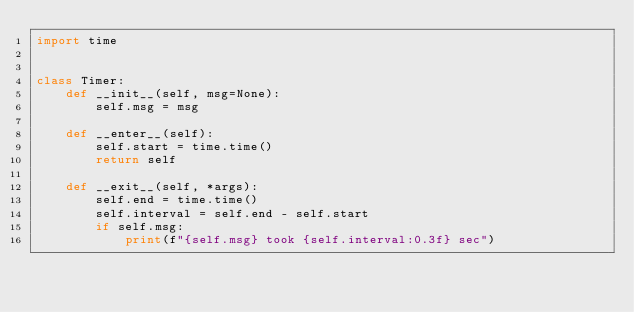Convert code to text. <code><loc_0><loc_0><loc_500><loc_500><_Python_>import time


class Timer:
    def __init__(self, msg=None):
        self.msg = msg

    def __enter__(self):
        self.start = time.time()
        return self

    def __exit__(self, *args):
        self.end = time.time()
        self.interval = self.end - self.start
        if self.msg:
            print(f"{self.msg} took {self.interval:0.3f} sec")
</code> 